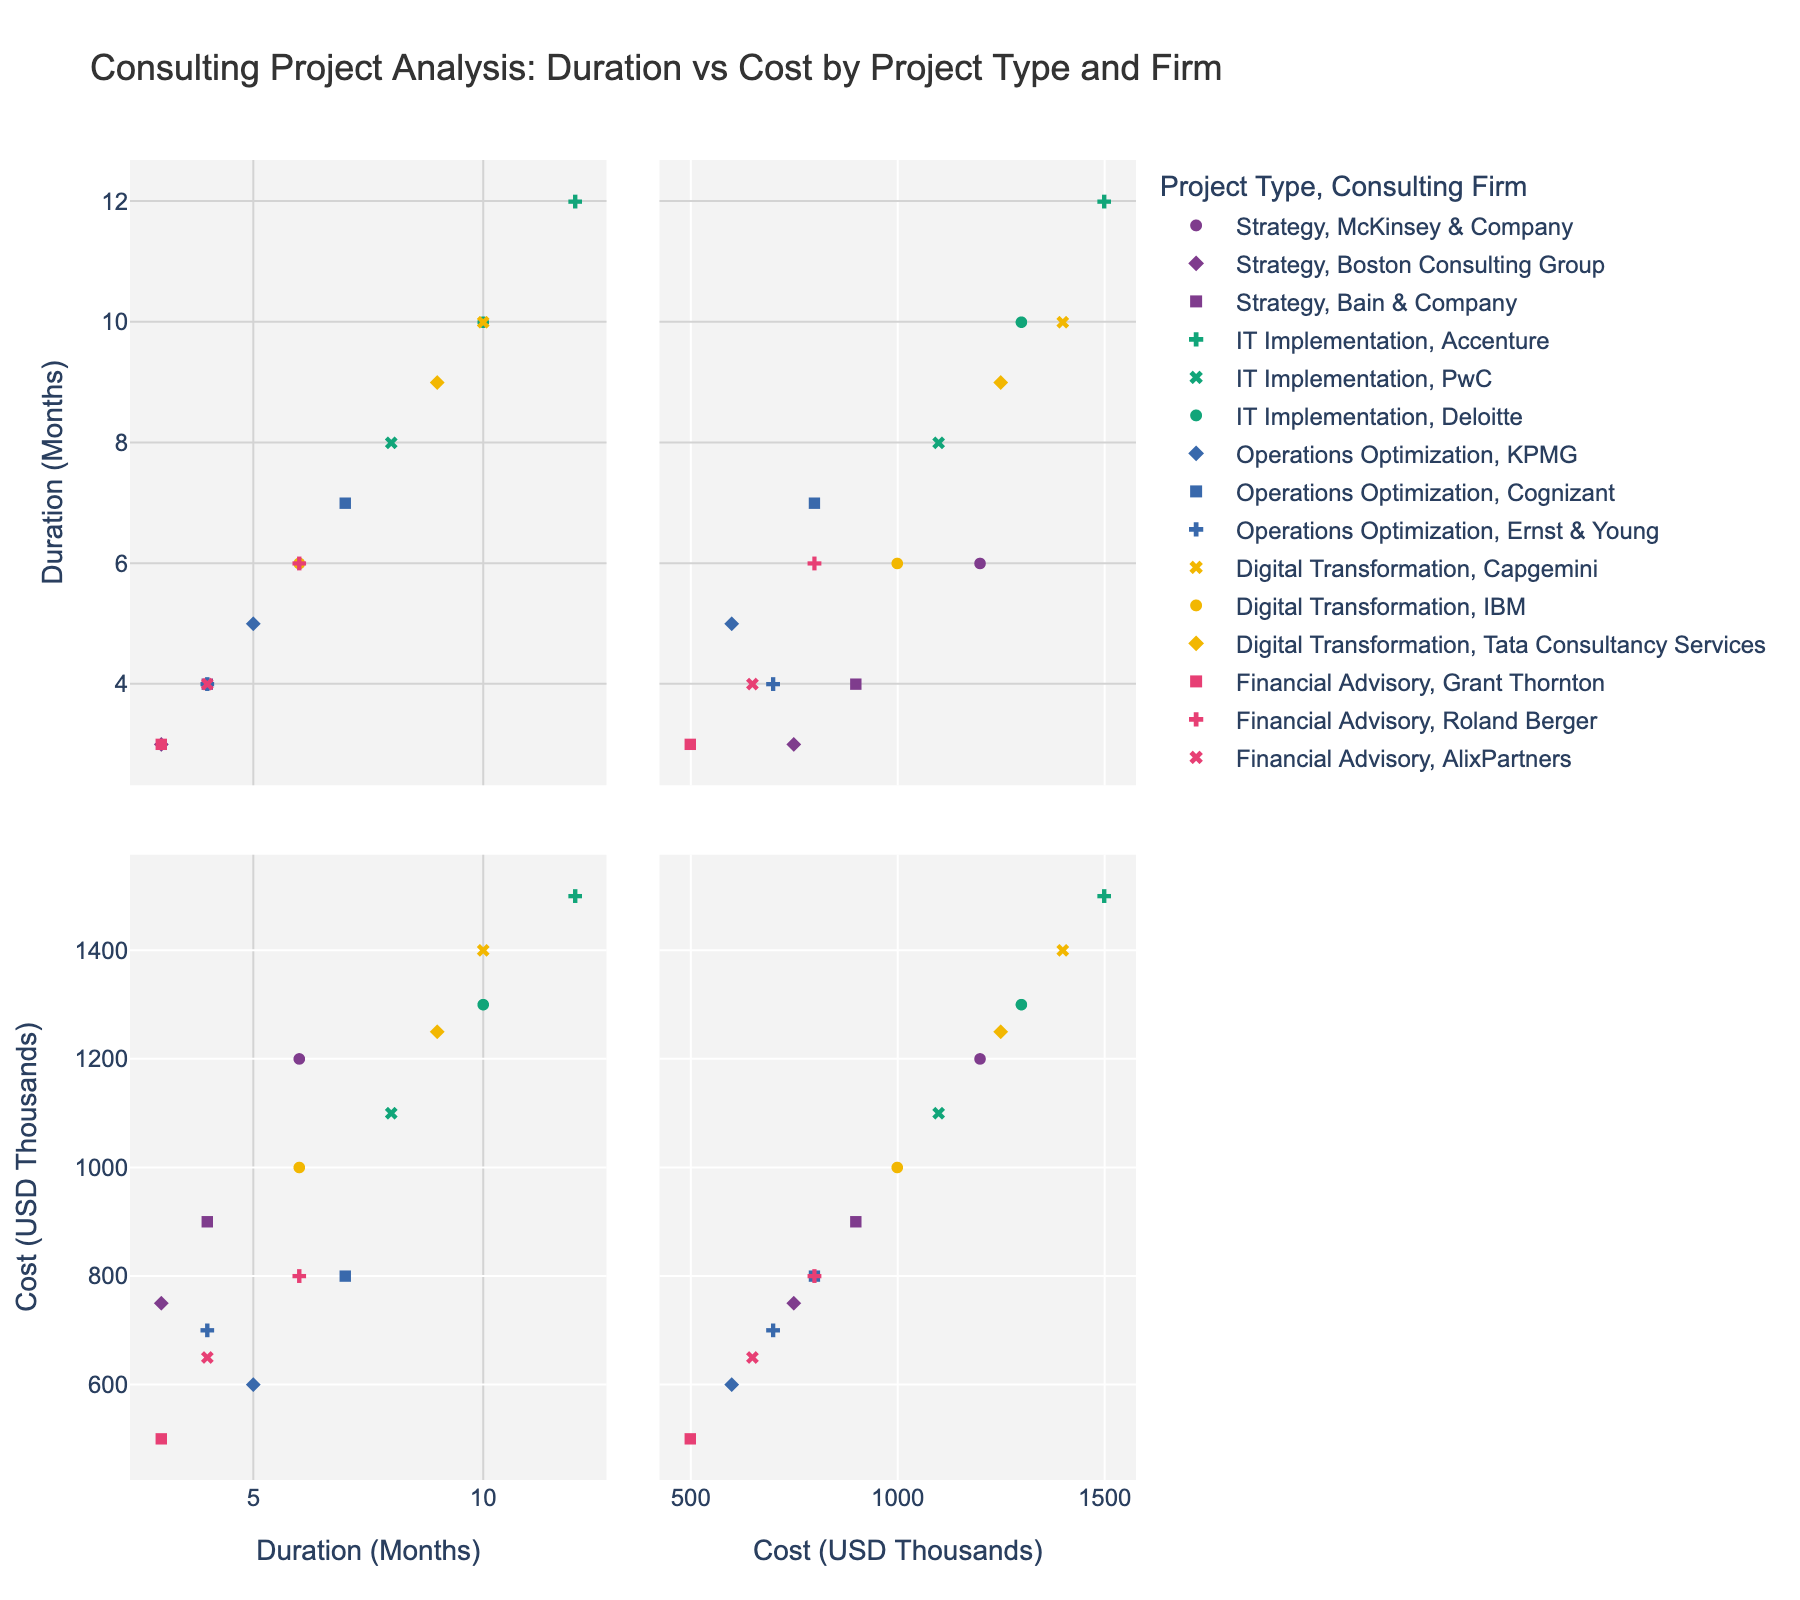How many data points are there in the figure? There are 15 rows in the dataset, corresponding to 15 individual data points in the SPLOM.
Answer: 15 What is the title of the figure? The title is displayed at the top of the figure, providing context for the data being visualized.
Answer: Consulting Project Analysis: Duration vs Cost by Project Type and Firm Which project type has the longest duration and what is its cost? The longest duration is found by observing the maximum x-axis value labeled "Duration (Months)". IT Implementation projects have the maximum duration of 12 months, associated with Accenture and costing 1500 USD thousands.
Answer: IT Implementation, 1500 Which consulting firm has the highest cost for Digital Transformation projects, and what is the cost? By identifying the data points labeled as "Digital Transformation" and comparing their y-axis values labeled "Cost (USD Thousands)", Capgemini has the highest cost at 1400 USD thousands.
Answer: Capgemini, 1400 What is the range of costs for Financial Advisory projects? By examining the y-axis values corresponding to "Financial Advisory" points, the minimum is 500 (Grant Thornton), and the maximum is 800 (Roland Berger). The range is calculated as 800 - 500.
Answer: 300 Among the firms working on Strategy projects, which has the shortest project duration, and how does its cost compare to others? By identifying the points labeled "Strategy" and comparing their x-axis values labeled "Duration (Months)", Boston Consulting Group has the shortest duration of 3 months. Its cost (750) is less than McKinsey & Company (1200) but more than Bain & Company (900).
Answer: Boston Consulting Group, 750 How do the costs of IT Implementation projects compare to those of Digital Transformation projects? By examining and comparing the y-axis values for "IT Implementation" and "Digital Transformation" points, the costs for IT Implementation range from 1100 to 1500, while Digital Transformation ranges from 1000 to 1400. Thus, IT Implementation projects generally have a slightly higher cost range.
Answer: IT Implementation projects generally cost more Which project type shows the most variability in cost, and what is the range of this variability? By comparing the range of y-axis values for each project type: IT Implementation (1100-1500), Strategy (750-1200), Digital Transformation (1000-1400), Operations Optimization (600-800), Financial Advisory (500-800). IT Implementation shows the most variability with a range of 400 (1500 - 1100).
Answer: IT Implementation, 400 Which firm has the lowest cost for Operations Optimization projects, and what is this cost? By looking at the "Operations Optimization" points and identifying the minimum y-axis value, KPMG has the lowest cost at 600 USD thousands.
Answer: KPMG, 600 